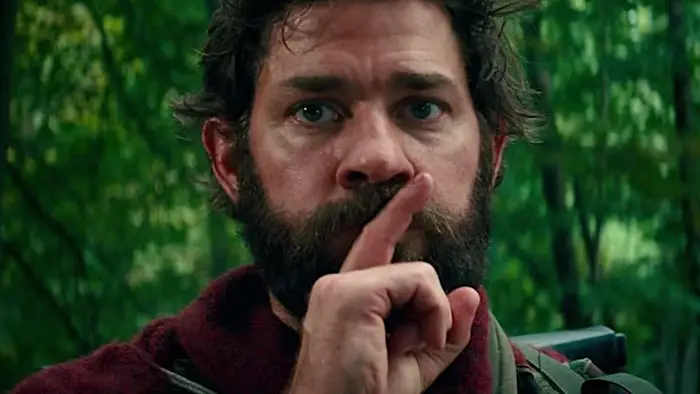What might this person be listening to or trying to detect? Given his pressing gesture for silence, it's likely that he is trying to listen carefully to the sounds surrounding him in the forest, which could range from the footsteps of others, suggesting perhaps a pursuit or evasion scenario, to the subtle movements of wildlife, indicating a setting where quietness is essential for safety. Is there any indication of what time of day it might be in this setting? The image does not provide a direct view of the sky, which makes it challenging to ascertain the exact time of day. However, the overall lighting and shadows suggest it could be either early morning or late afternoon, times when light tends to be softer and more diffuse. 